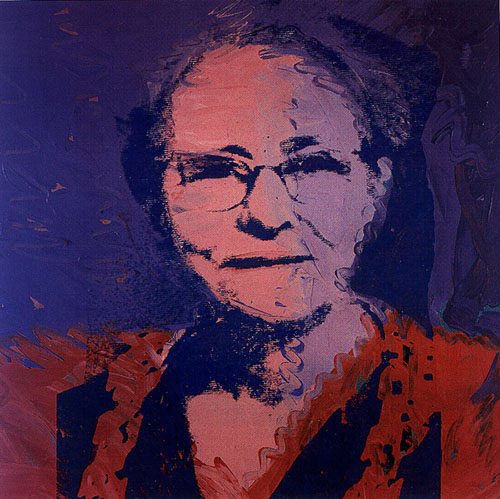Analyze the image in a comprehensive and detailed manner. The image is a striking portrait of a woman, masterfully rendered in the distinctive pop art style. Her face and upper body dominate the frame, providing a focal point for the viewer. The woman's white hair and glasses offer a sharp contrast against her vibrant red-orange blouse, which stands out vividly against the deep blue background. The background itself is a colorful blend of orange and purple hues, adding complexity and depth to the overall composition. This artwork skillfully combines painting and printmaking techniques, evident in the detailed rendering of the woman's face and blouse contrasted with the more abstract background. This fusion is characteristic of pop art, celebrated for its bold colors and dramatic visual effects. 